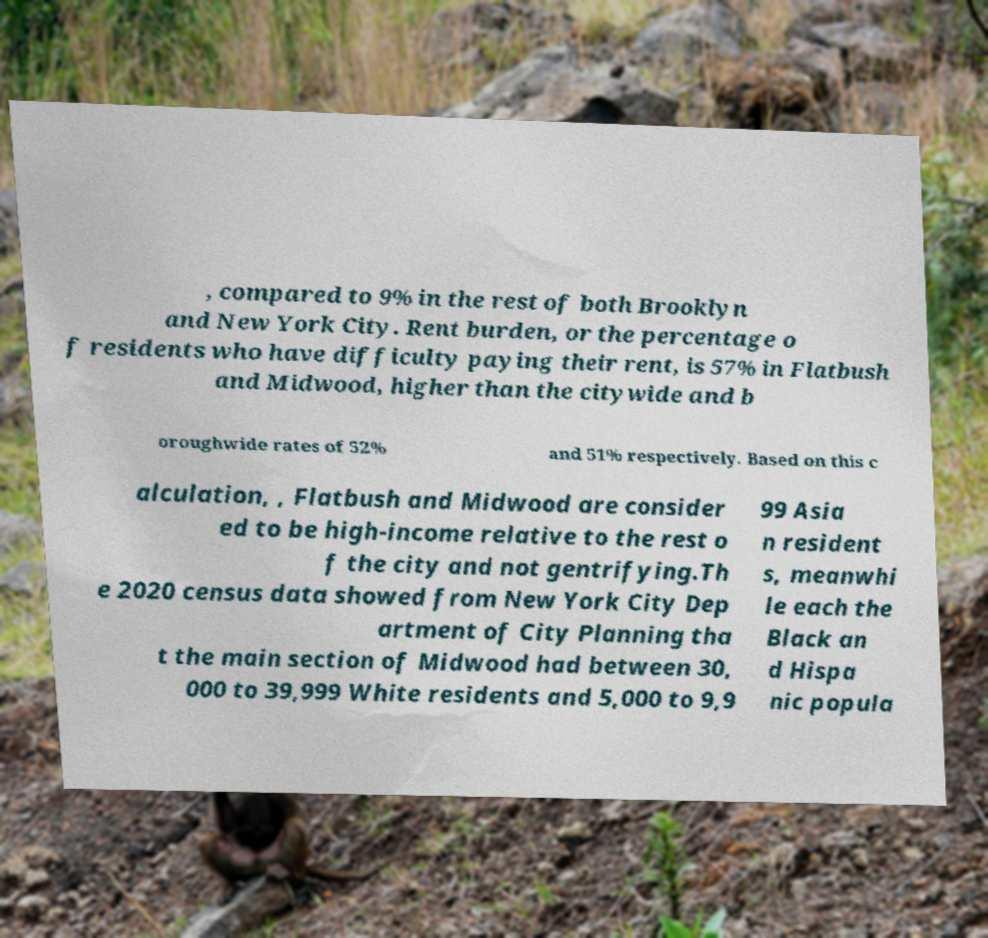Please read and relay the text visible in this image. What does it say? , compared to 9% in the rest of both Brooklyn and New York City. Rent burden, or the percentage o f residents who have difficulty paying their rent, is 57% in Flatbush and Midwood, higher than the citywide and b oroughwide rates of 52% and 51% respectively. Based on this c alculation, , Flatbush and Midwood are consider ed to be high-income relative to the rest o f the city and not gentrifying.Th e 2020 census data showed from New York City Dep artment of City Planning tha t the main section of Midwood had between 30, 000 to 39,999 White residents and 5,000 to 9,9 99 Asia n resident s, meanwhi le each the Black an d Hispa nic popula 